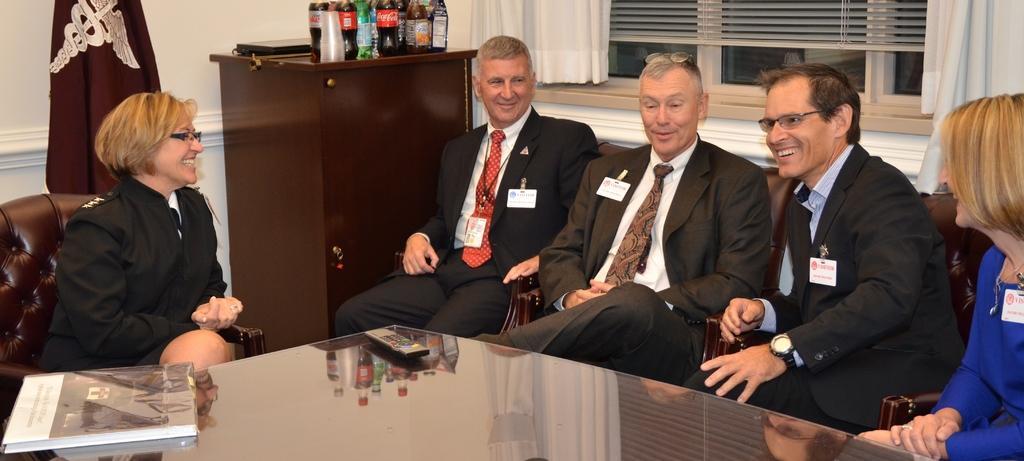Describe this image in one or two sentences. In this image we can see there are people. There is a remote and a book on the table. There are bottles, glasses and objects on the cupboard. There are curtains and windows.   